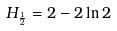<formula> <loc_0><loc_0><loc_500><loc_500>H _ { \frac { 1 } { 2 } } = 2 - 2 \ln 2</formula> 